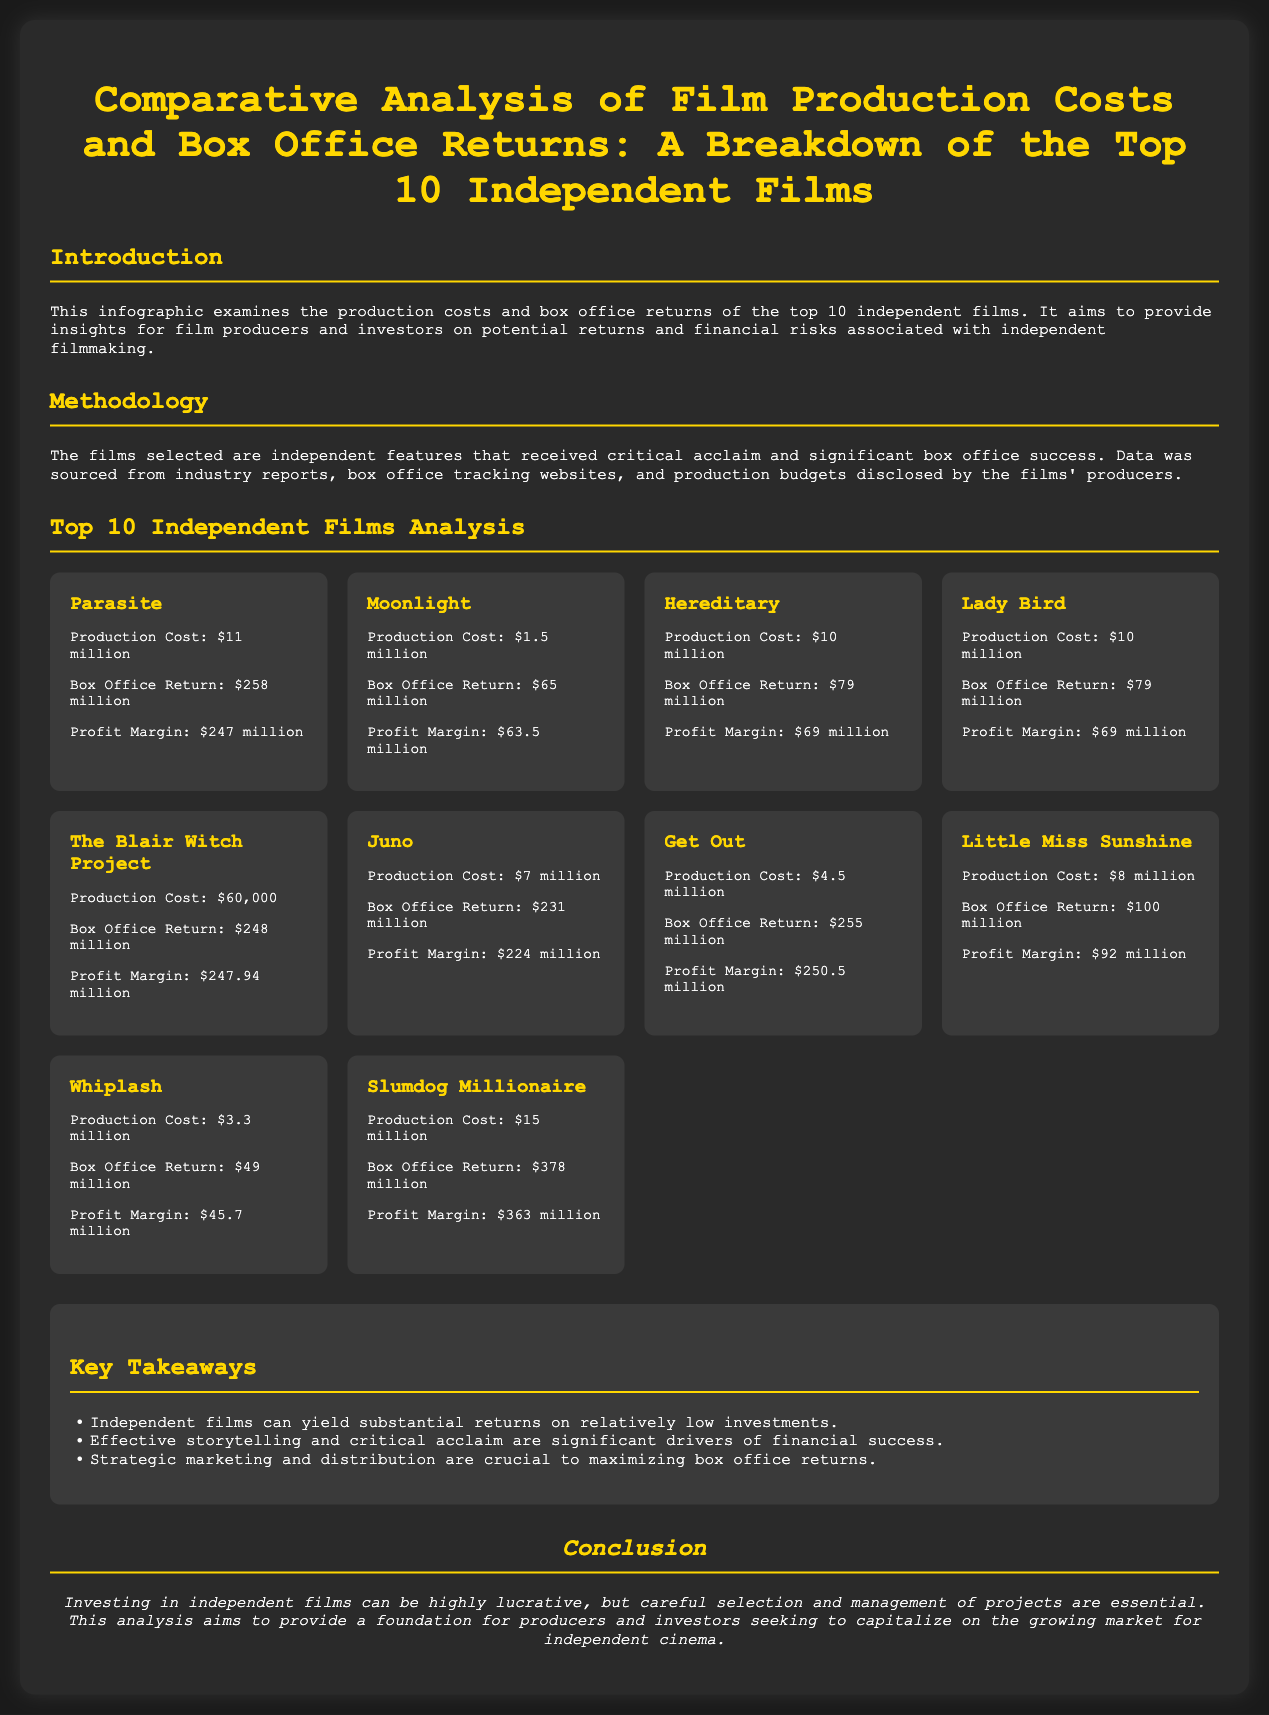What is the production cost of Parasite? The production cost of Parasite is listed in the document as $11 million.
Answer: $11 million What film had the highest box office return? The document states that Slumdog Millionaire had the highest box office return at $378 million.
Answer: $378 million What is the profit margin of Get Out? According to the document, the profit margin of Get Out is calculated as $250.5 million.
Answer: $250.5 million How many films listed have a production cost of $10 million? The document lists three films with a production cost of $10 million: Hereditary, Lady Bird, and another.
Answer: 2 What is the total profit margin of all films combined? The total profit margin is not explicitly stated but can be calculated by adding all profit margins. The document indicates the total profit margins of listed films.
Answer: N/A Which film had a production cost below $100,000? The document notes The Blair Witch Project had a production cost of $60,000.
Answer: $60,000 What are the key drivers of financial success mentioned? The document lists effective storytelling, critical acclaim, and strategic marketing as key drivers.
Answer: Effective storytelling and critical acclaim What is the conclusion of the analysis? The conclusion emphasizes the lucrativeness of investing in independent films with careful selection and management.
Answer: Careful selection and management 